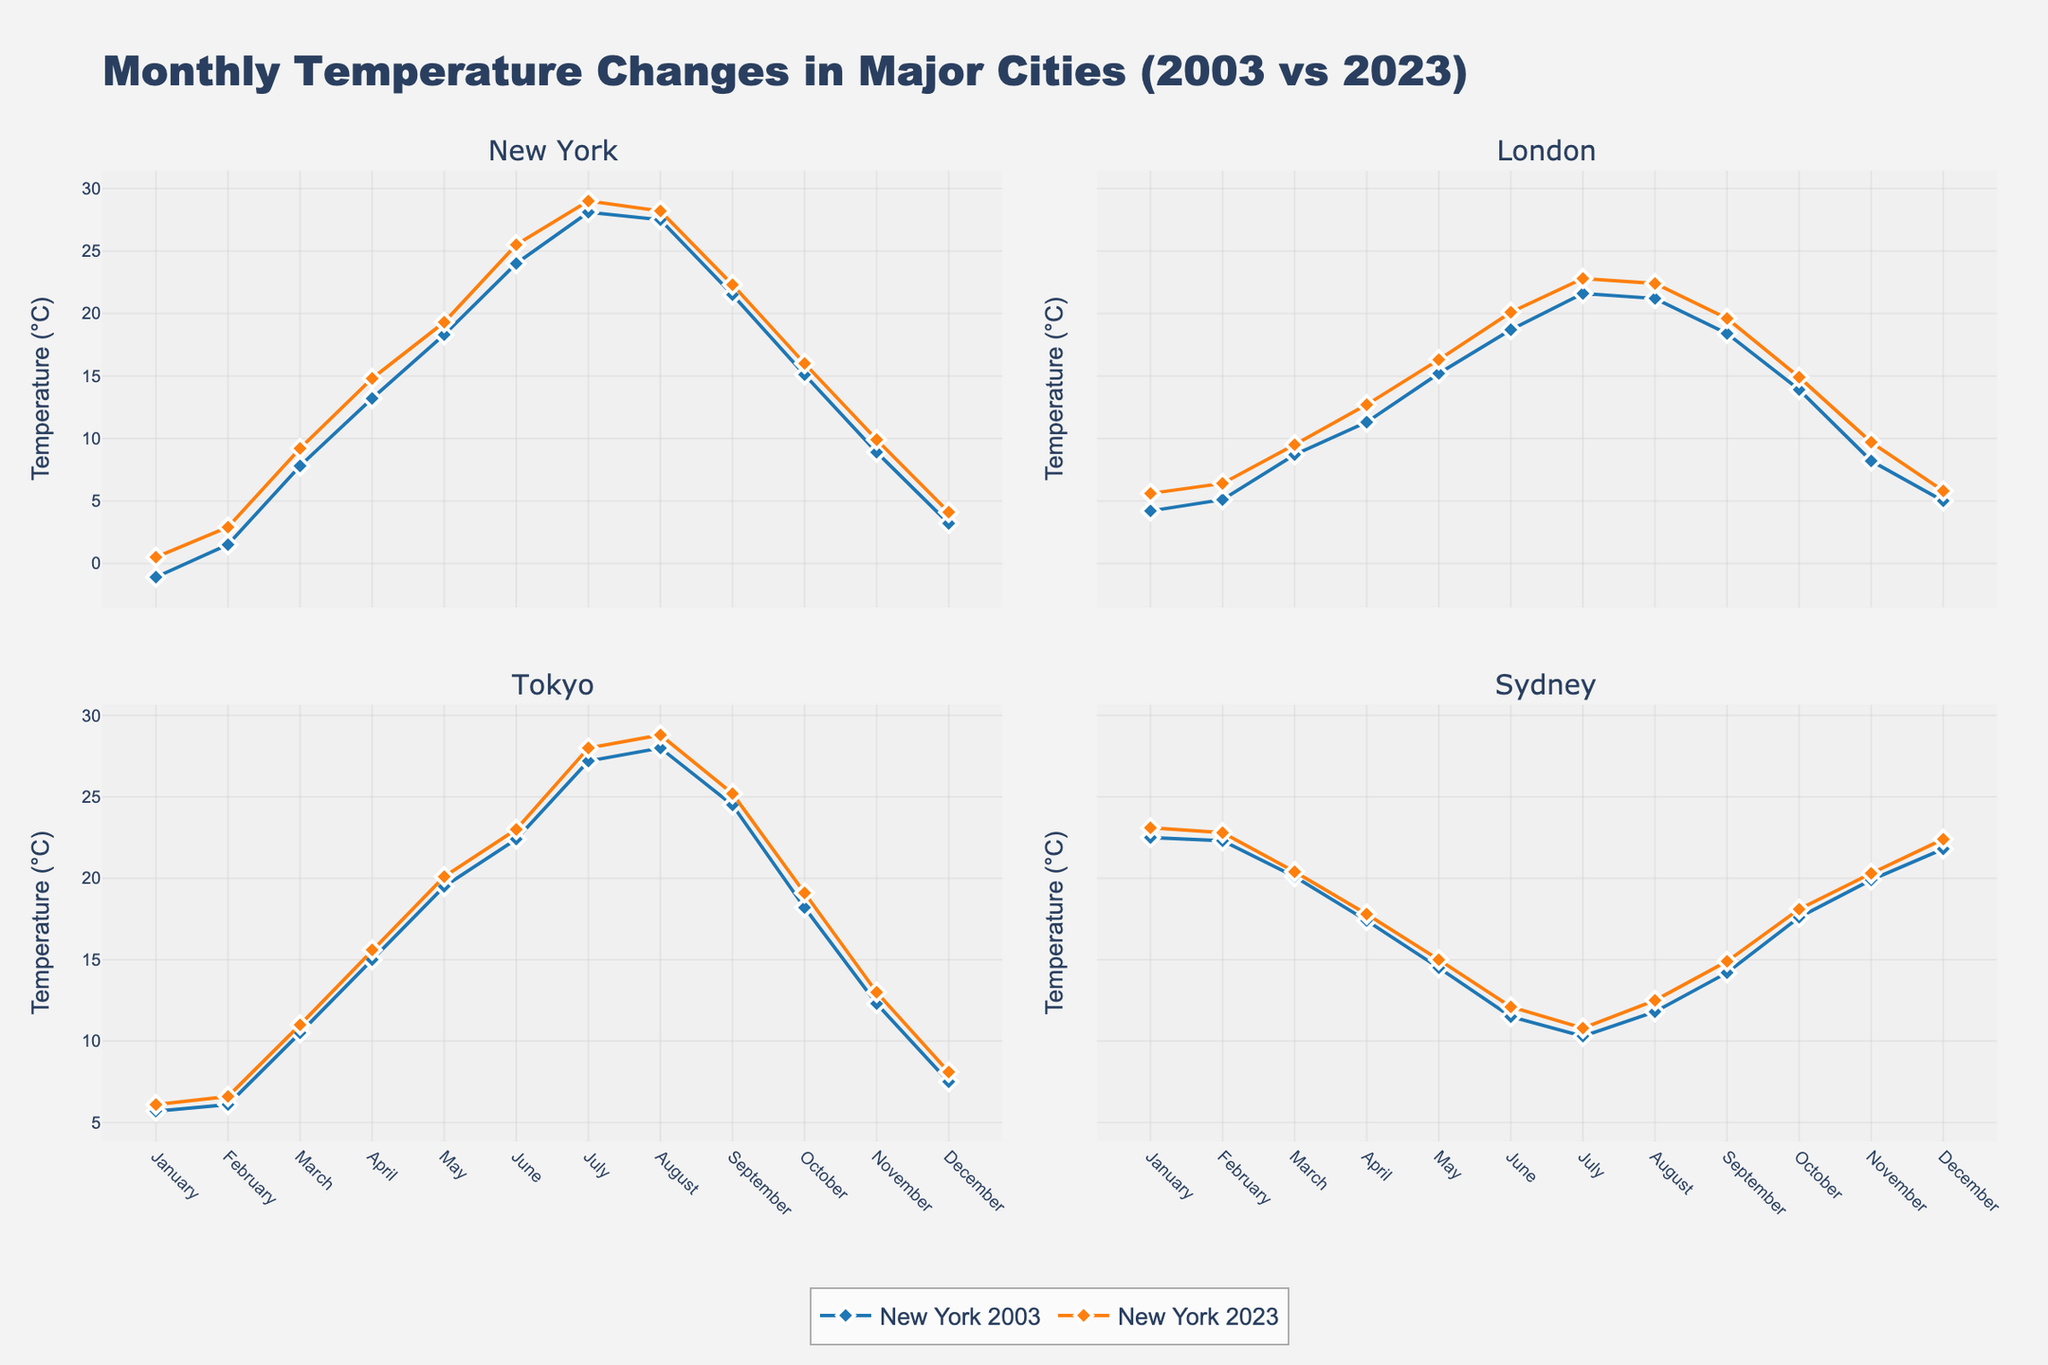What is the title of the figure? The title of the figure is typically placed at the top and is intended to describe the primary subject of the data visualization. By looking at the top of this figure, we can see the title clearly displayed.
Answer: Monthly Temperature Changes in Major Cities (2003 vs 2023) How many subplots are there in the figure? This figure uses subplots to display data for multiple cities simultaneously. By counting the number of subplot titles or viewing the overall structure, we can determine the number of subplots.
Answer: 4 Which city had the highest temperature in July of 2023? To answer this, we need to look at the temperature data points corresponding to July 2023 for all four cities and compare the values. The city's subplot with the highest data point in July 2023 is the answer.
Answer: New York What is the temperature difference in New York between January 2003 and January 2023? Identify the temperature for January 2003 and January 2023 in New York's subplot, then calculate the difference by subtracting the earlier value from the later one.
Answer: 1.6°C Which year had higher average temperatures in Sydney, 2003 or 2023? To determine this, find the average temperature for all the months in 2003 and then in 2023 within the Sydney subplot. Compare the two averages to see which one is higher.
Answer: 2023 What is the common trend observed in the temperature changes from 2003 to 2023 across all cities? Examine each subplot and identify any patterns in the year-to-year temperature changes. A common trend would be observed if all cities show similar patterns, such as an increase in temperature over the years.
Answer: General temperature increase In which month did London experience the smallest temperature increase between 2003 and 2023? Compare the temperatures for each month between 2003 and 2023 in the London subplot to identify the month with the smallest difference.
Answer: March Compare the winter temperatures (December, January, and February) between Tokyo and Sydney in 2023. Which city was warmer? Extract the temperature data for December, January, and February 2023 from the Tokyo and Sydney subplots. Summarize or average these values for each city, then compare the results to determine which city was warmer.
Answer: Sydney How does seasonal temperature variation in 2003 compare to 2023 in New York? For both 2003 and 2023, observe the temperature changes through the months in New York's subplot. Determine if there is a significant difference in the range or pattern of temperatures over the year.
Answer: Larger variation in 2023 Which month shows a peak summer temperature in Tokyo, and how has this temperature changed from 2003 to 2023? Identify the highest summer temperature in the Tokyo subplot for both 2003 and 2023. Note the corresponding month and compare the temperatures to understand the change.
Answer: August, increased by 0.8°C 